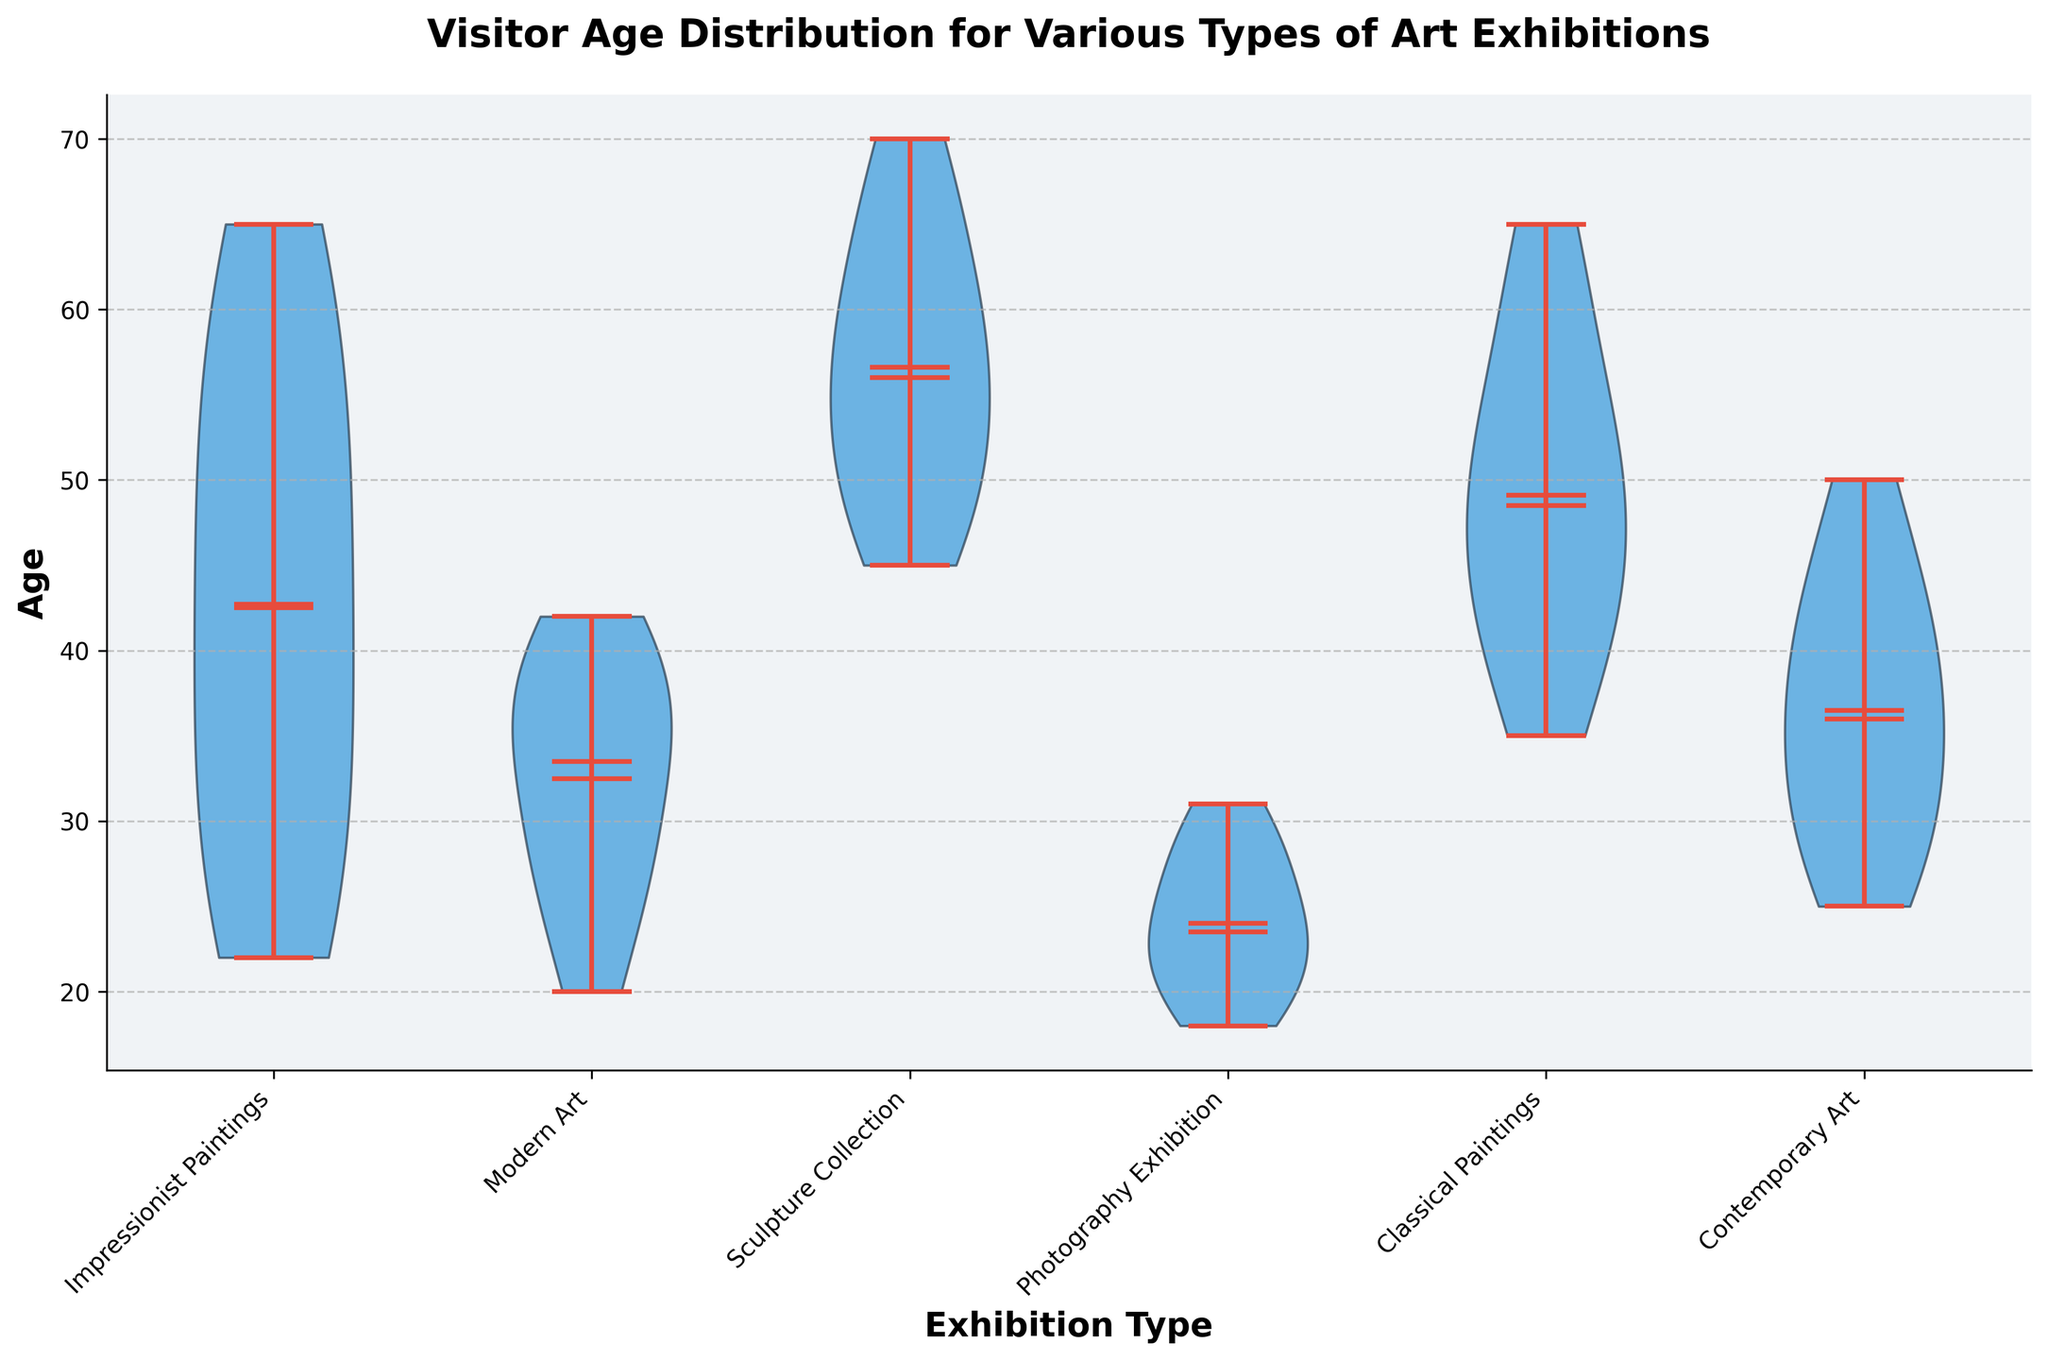What is the title of the plot? The plot’s title is a text element typically located at the top of the figure. It is designed to give a concise summary of what the figure is about.
Answer: Visitor Age Distribution for Various Types of Art Exhibitions What is the age range for the Impressionist Paintings exhibition? By observing the vertical span of the violin plot for Impressionist Paintings, you can see the minimum and maximum ages.
Answer: 22-65 Which exhibition has the youngest visitors? Look at the bottom of the violins to see which one starts at the lowest age.
Answer: Photography Exhibition What is the median age for the Classical Paintings exhibition? This is identified by the median mark within the violin plot for Classical Paintings. Median lines are usually marked prominently.
Answer: 50 Which exhibitions have a median age of 40 or higher? Identify the median marks for each exhibition and note which ones meet or exceed 40.
Answer: Impressionist Paintings, Classical Paintings, Sculpture Collection, Contemporary Art Which exhibition has the largest age spread? This is determined by the length of the violin plot; the longer it is, the greater the age spread.
Answer: Sculpture Collection Is the mean age for Modern Art higher or lower than Contemporary Art? Compare the positions of the means (typically indicated by a mark or line) of the Modern Art and Contemporary Art violins.
Answer: Lower What does the "showmedians" part of the violin plot signify? "Showmedians" refers to the visual representation of the median age line in each violin plot. This helps identify the central tendency of each group.
Answer: The median line For which exhibition does the mean and median age appear to be closest? For each exhibition, visually compare the proximity of the mean and median lines.
Answer: Modern Art How do the age distributions vary between Modern Art and Photography Exhibition? Compare the shapes, spread, and positions of the violin plots for Modern Art and Photography Exhibition for differences in how ages are distributed.
Answer: Photography Exhibition has a younger age distribution, while Modern Art has a relatively higher and narrower range 